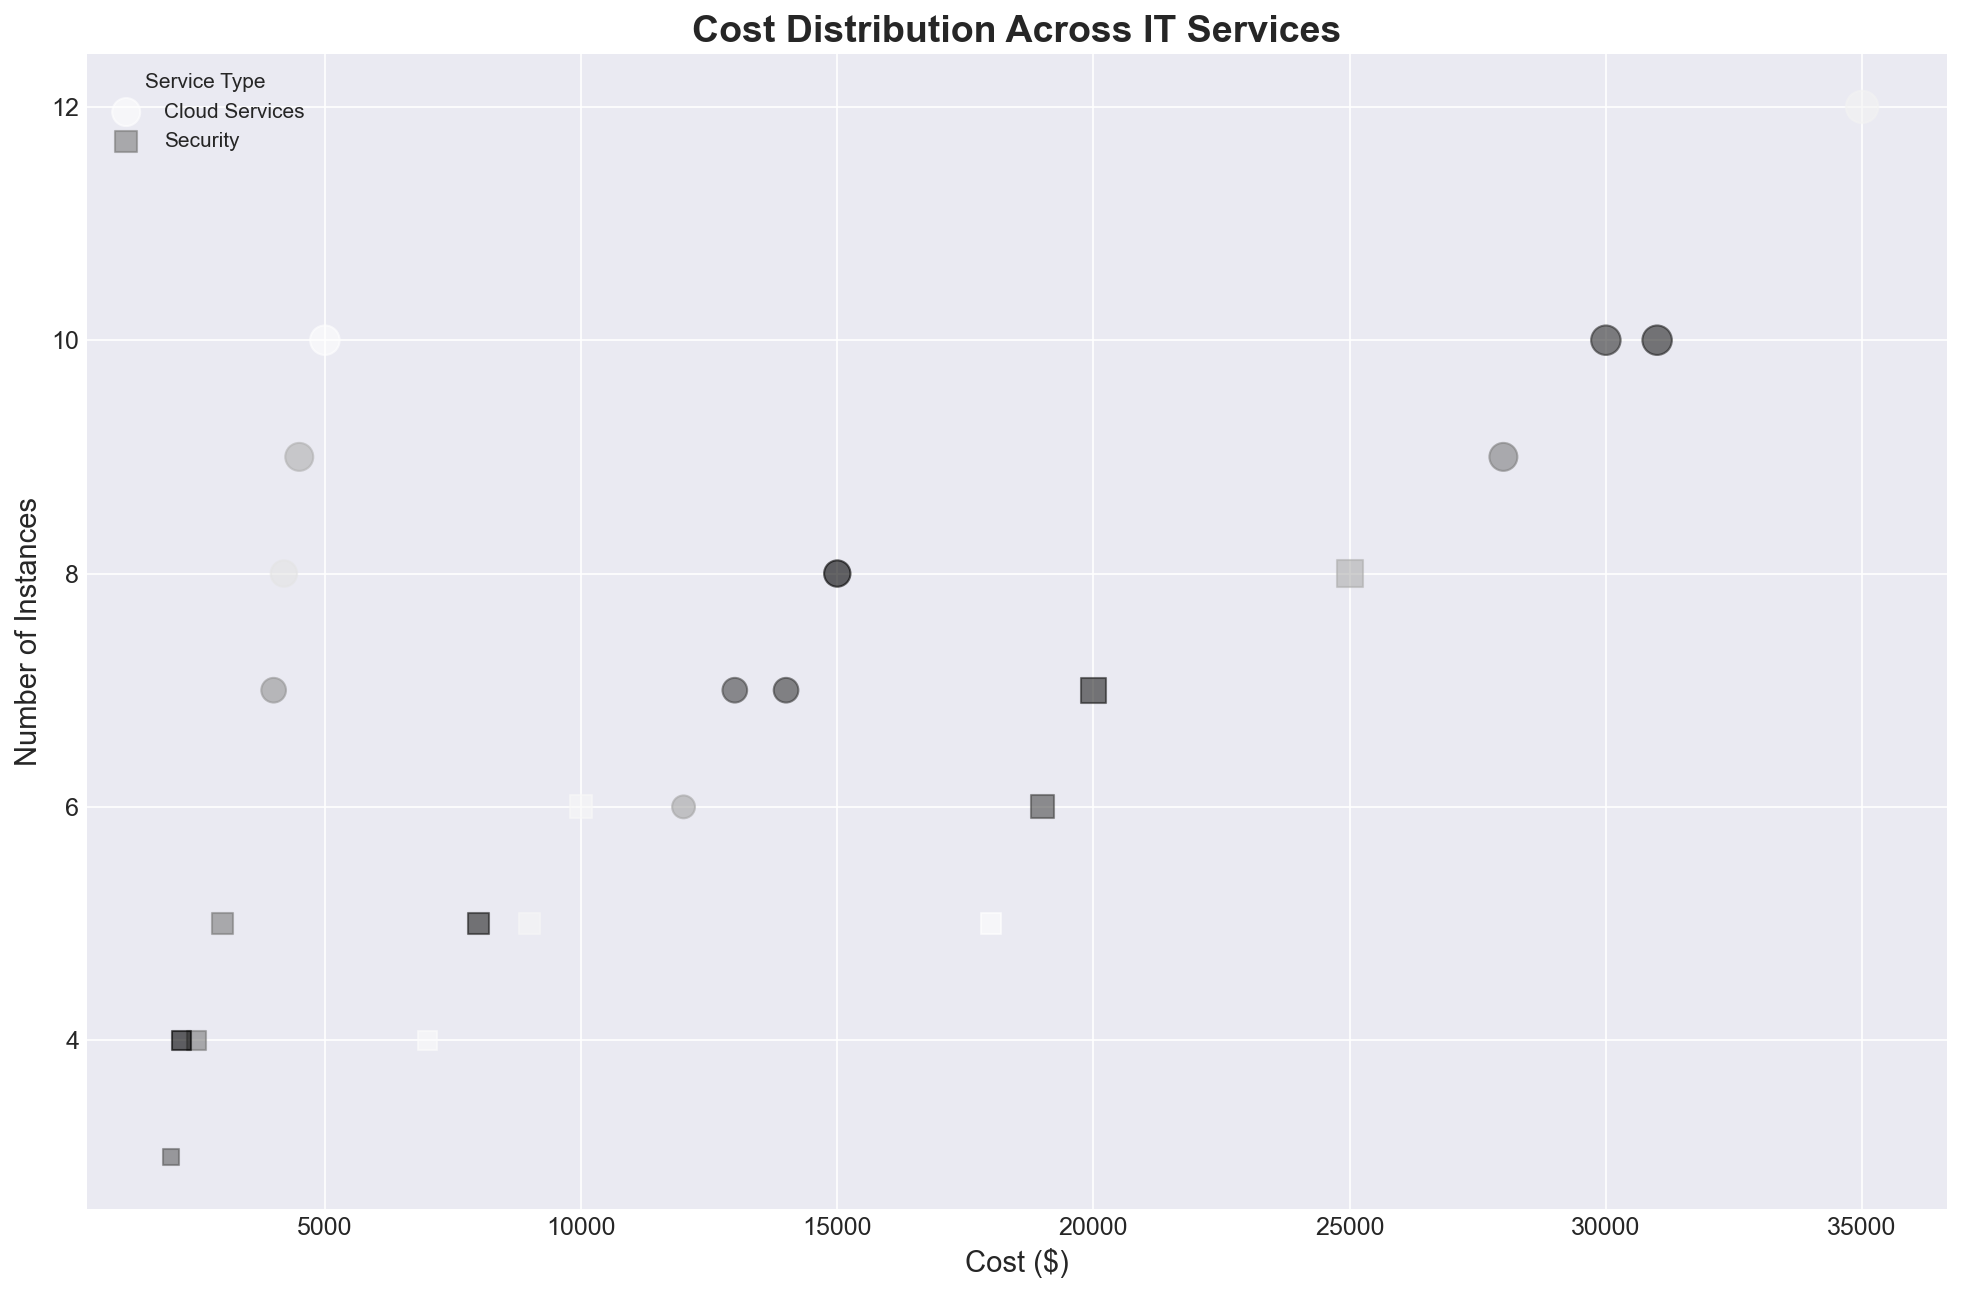Which Industry and Company Size has the highest cost for Cloud Services? Look at the bubble chart where "Cloud Services" are represented by circles. Identify the largest bubble based on the cost axis. The highest cost for Cloud Services is in the Finance industry within the 201-500 company size segment.
Answer: Finance, 201-500 How does the number of instances for Security services compare between the Healthcare and Retail industries for the 51-200 company size group? Compare the squares in the 51-200 company size for the Healthcare and Retail industries. For Healthcare, the number of instances is 5, and for Retail, it is also 5.
Answer: Equal What is the sum of costs for Security services in the Healthcare industry across all company sizes? Sum the costs of Security services for all company sizes in Healthcare: 2500 (10-50) + 9000 (51-200) + 20000 (201-500). This results in 31500.
Answer: 31500 Which service type has a greater number of instances in the Manufacturing industry for the 10-50 company size category, Cloud Services or Security? Compare the sizes of the circles and squares in the Manufacturing industry for the 10-50 company size based on the "Number of Instances" axis. Cloud Services has 7 instances whereas Security has 3.
Answer: Cloud Services Which company size category shows the most significant difference in cost between Cloud Services and Security in the Finance industry? Check the costs of Cloud Services and Security in different company sizes within the Finance industry and compute their differences: 10-50: 5000-3000=2000, 51-200: 15000-10000=5000, 201-500: 35000-25000=10000. The largest difference is within the 201-500 company size.
Answer: 201-500 For which industry is the total cost of Security services most evenly distributed across all company sizes? Evaluate the cost of Security services for each industry and check the variation across company sizes. In Retail, the Security costs are relatively close: 2200 (10-50), 8000 (51-200), 19000 (201-500). Compare this to the other variations which are larger.
Answer: Retail Which industry and company size have the smallest number of instances for Security services? Look across all industry and company sizes for the smallest bubble size among Security services, identified by squares. The smallest number of instances is for Manufacturing in the 10-50 company size category with 3 instances.
Answer: Manufacturing, 10-50 How does the cost of Cloud Services in Healthcare compare to that of Security Services in Finance for the 51-200 company size? Cross-reference the costs of Cloud Services in Healthcare and Security Services in Finance for the 51-200 company size. Cloud Services in Healthcare costs 14000, whereas Security in Finance costs 10000.
Answer: Cloud Services in Healthcare is higher Which industry has the highest total number of instances for all service types combined? Sum the number of instances for all services across all company sizes within each industry and compare the totals. Finance industry has 63 instances in total (10+5, 8+6, 12+8).
Answer: Finance What is the cost difference for Security services between the largest company size and the smallest company size in the Retail industry? Subtract the cost of Security Services for the 10-50 company size from the cost for the 201-500 company size in the Retail industry: 19000-2200=16800.
Answer: 16800 